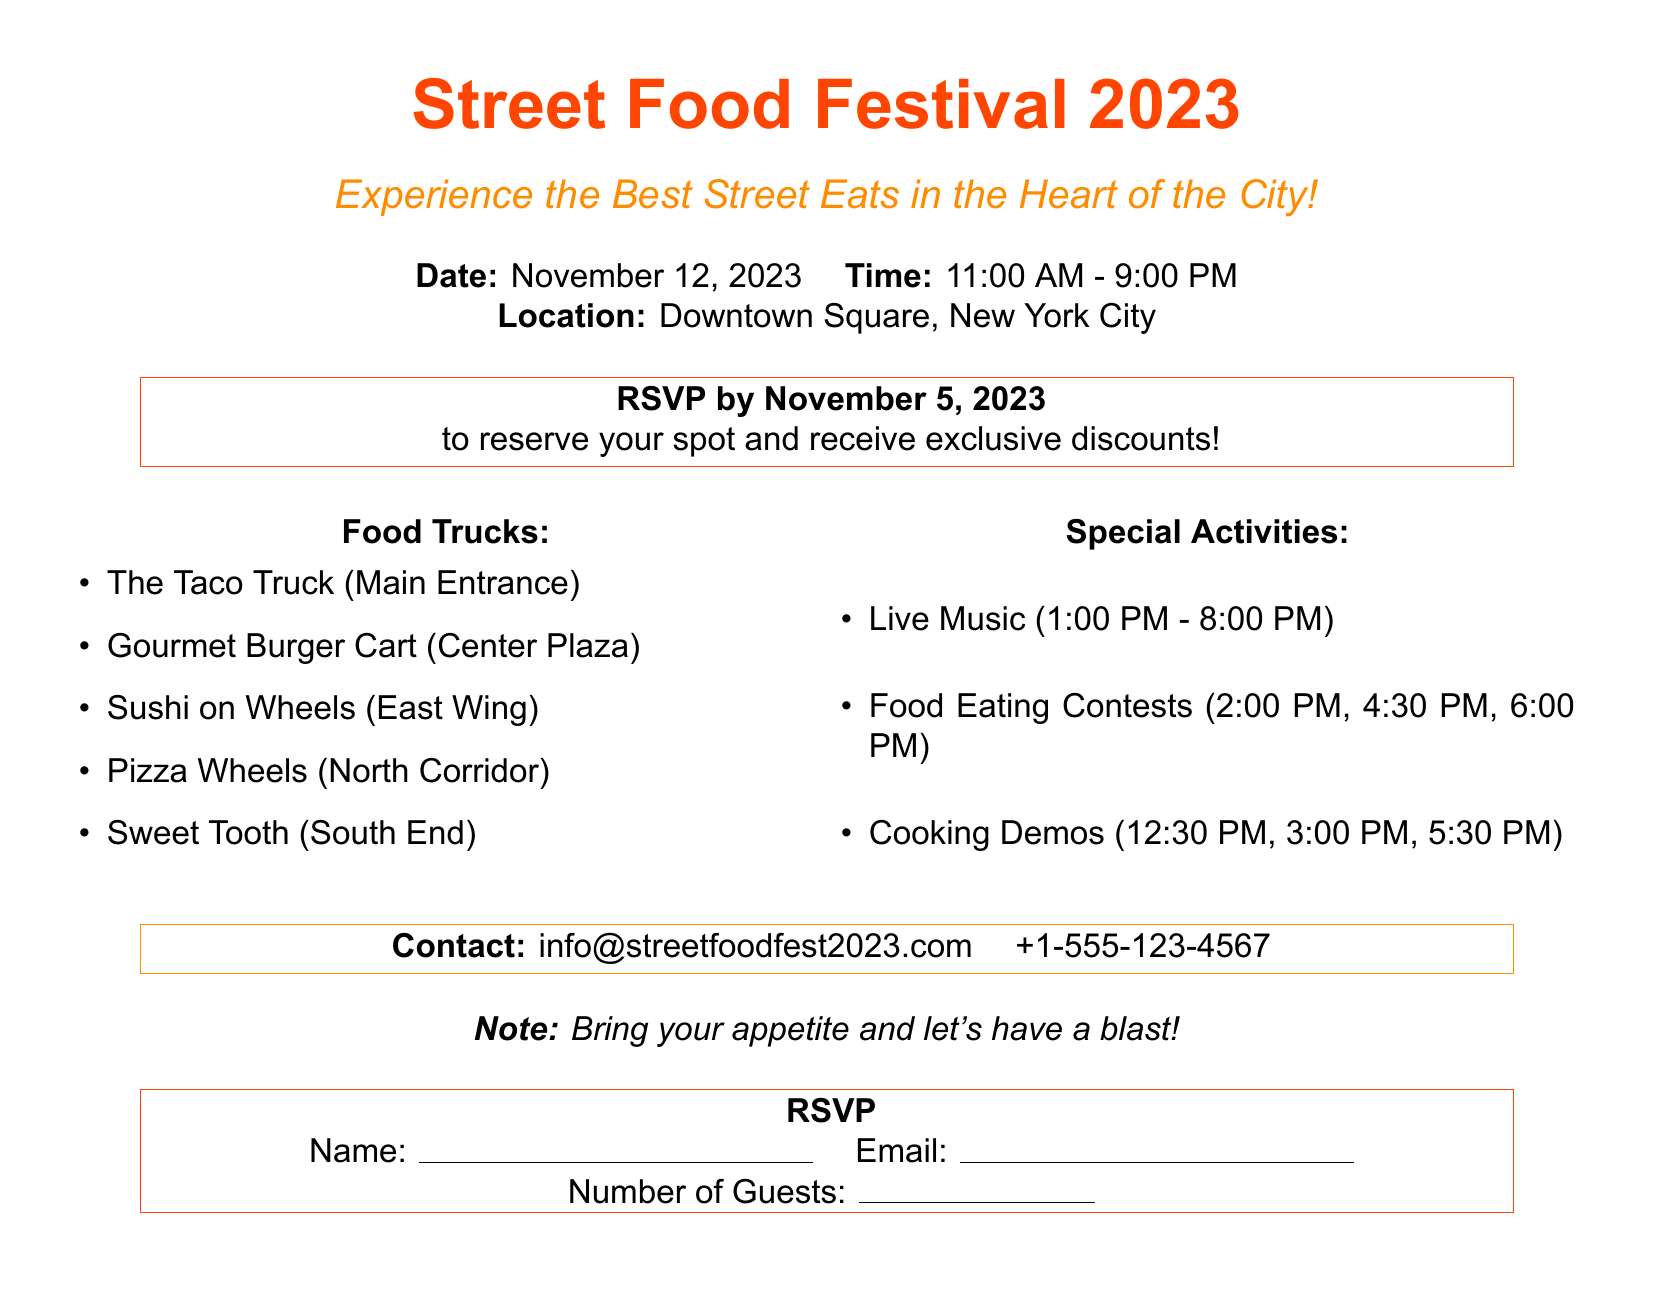What is the date of the festival? The date of the festival is explicitly stated in the document as November 12, 2023.
Answer: November 12, 2023 What time does the festival start? The festival starts at 11:00 AM as mentioned in the timetable of the document.
Answer: 11:00 AM Which food truck is located at the main entrance? The document lists the food trucks along with their locations, stating that The Taco Truck is at the Main Entrance.
Answer: The Taco Truck How many food eating contests are scheduled? The document specifies that there are three food eating contests listed at different times.
Answer: 3 What is the contact email for the event? The contact email for inquiries about the festival is given in the document as info@streetfoodfest2023.com.
Answer: info@streetfoodfest2023.com What special activity occurs at 2:00 PM? The scheduling of activities shows that a Food Eating Contest is planned for 2:00 PM.
Answer: Food Eating Contest What is the last hour of the festival? The end time of the festival is clearly stated in the document as 9:00 PM.
Answer: 9:00 PM How many cooking demonstrations are mentioned? The document lists three cooking demonstrations at different times, indicating there are three.
Answer: 3 